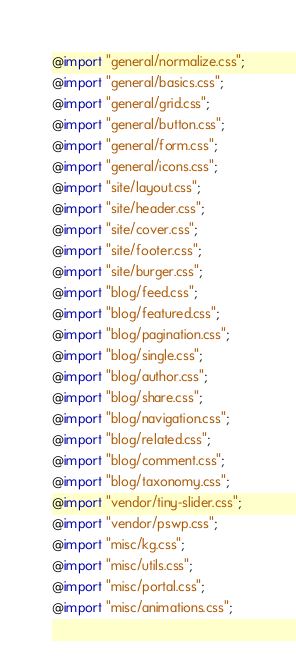<code> <loc_0><loc_0><loc_500><loc_500><_CSS_>@import "general/normalize.css";
@import "general/basics.css";
@import "general/grid.css";
@import "general/button.css";
@import "general/form.css";
@import "general/icons.css";
@import "site/layout.css";
@import "site/header.css";
@import "site/cover.css";
@import "site/footer.css";
@import "site/burger.css";
@import "blog/feed.css";
@import "blog/featured.css";
@import "blog/pagination.css";
@import "blog/single.css";
@import "blog/author.css";
@import "blog/share.css";
@import "blog/navigation.css";
@import "blog/related.css";
@import "blog/comment.css";
@import "blog/taxonomy.css";
@import "vendor/tiny-slider.css";
@import "vendor/pswp.css";
@import "misc/kg.css";
@import "misc/utils.css";
@import "misc/portal.css";
@import "misc/animations.css";
</code> 